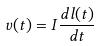Convert formula to latex. <formula><loc_0><loc_0><loc_500><loc_500>v ( t ) = I \frac { d l ( t ) } { d t }</formula> 